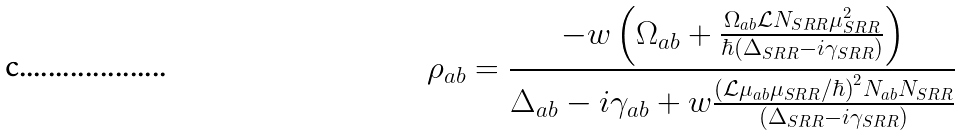Convert formula to latex. <formula><loc_0><loc_0><loc_500><loc_500>\rho _ { a b } = \frac { - w \left ( \Omega _ { a b } + \frac { \Omega _ { a b } \mathcal { L } N _ { S R R } \mu _ { S R R } ^ { 2 } } { \hbar { ( } \Delta _ { S R R } - i \gamma _ { S R R } ) } \right ) } { \Delta _ { a b } - i \gamma _ { a b } + w \frac { ( \mathcal { L } \mu _ { a b } \mu _ { S R R } / \hbar { ) } ^ { 2 } N _ { a b } N _ { S R R } } { ( \Delta _ { S R R } - i \gamma _ { S R R } ) } }</formula> 